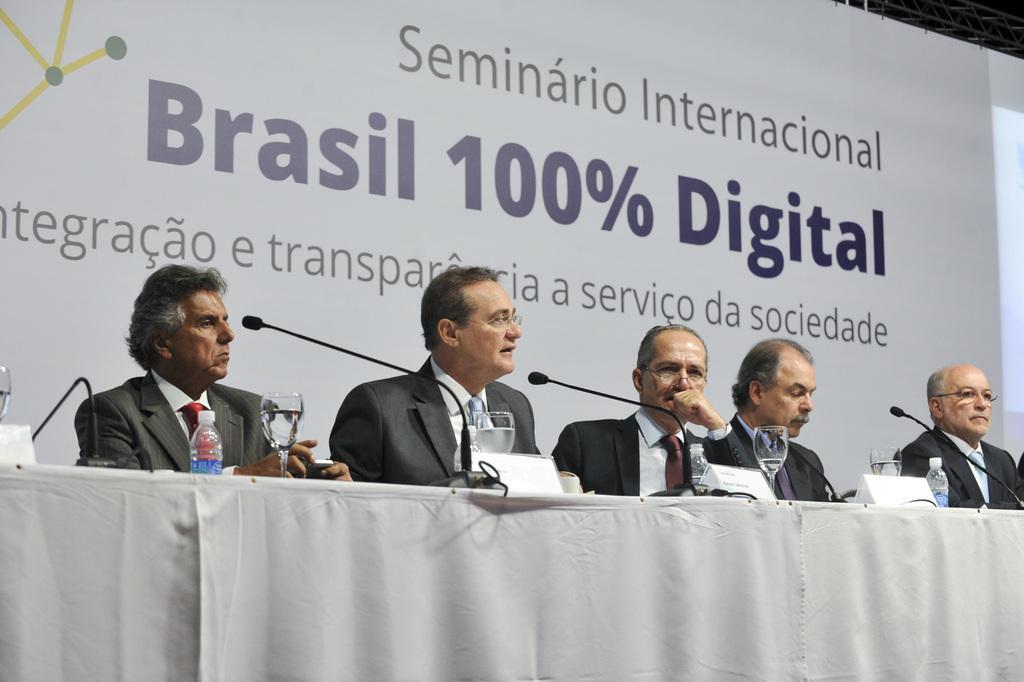How would you summarize this image in a sentence or two? In this image we can see a few people sitting, in front of them there is a table covered with white color cloth, on the table, we can see water bottle, mice, glasses and some other objects, in the background we can see a poster with some text. 